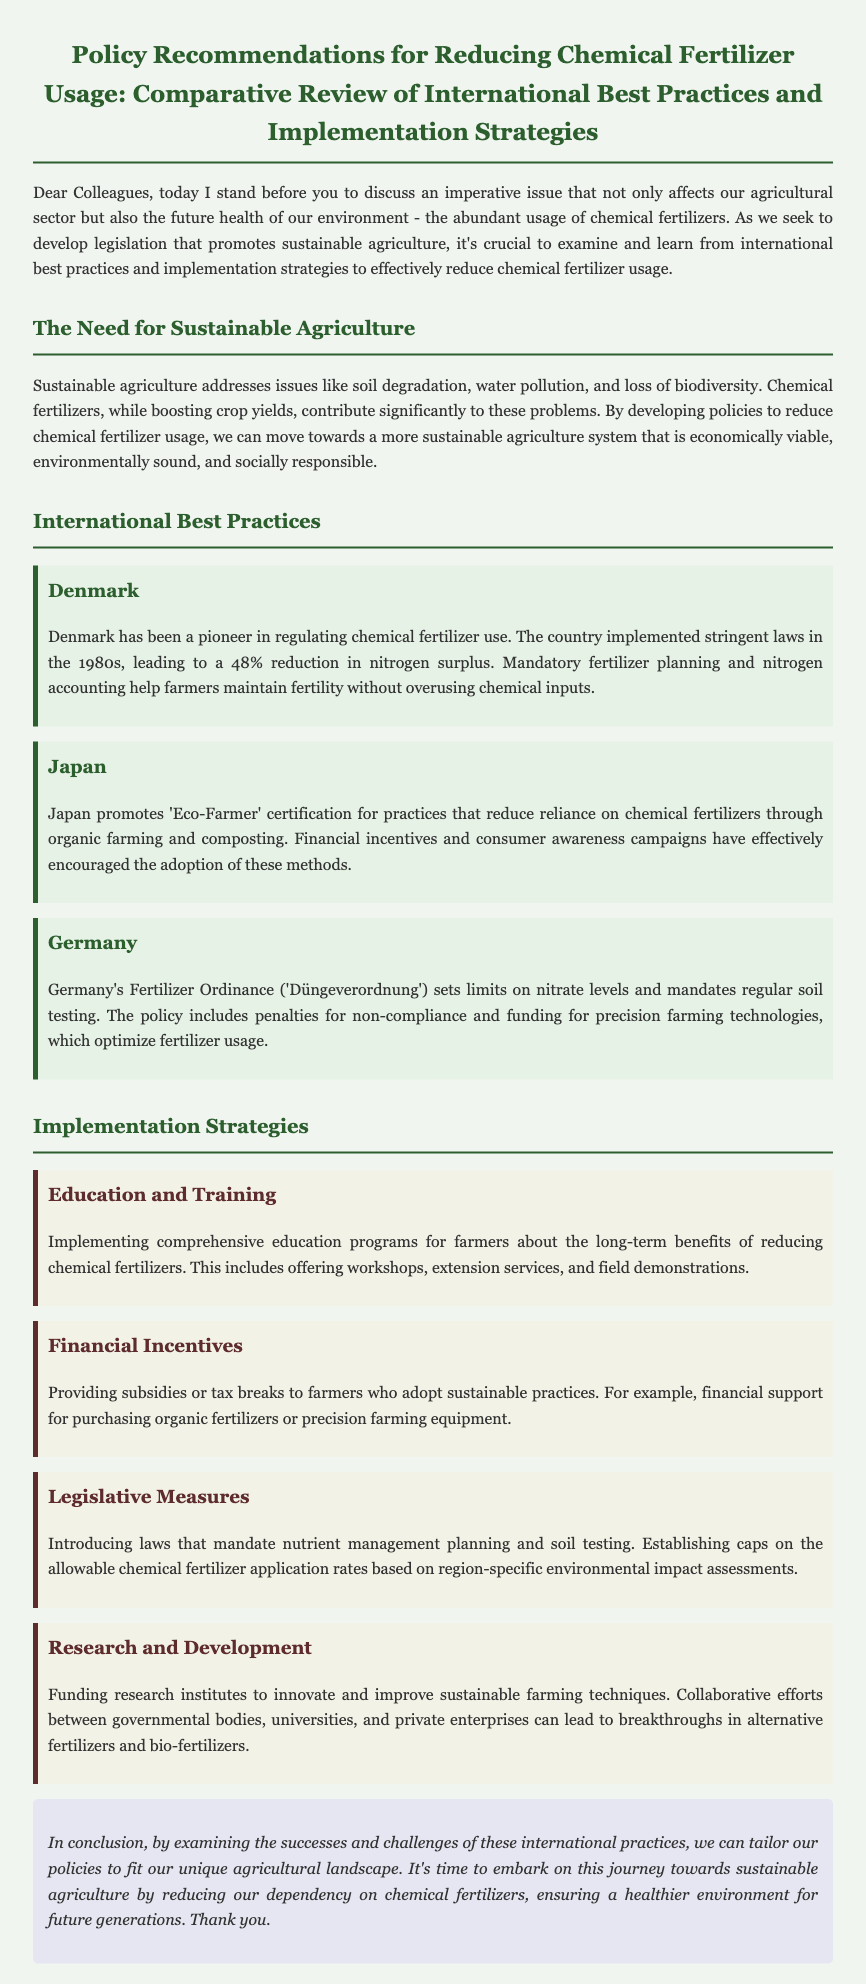What is the primary issue addressed in the document? The document emphasizes the imperative issue of abundant usage of chemical fertilizers affecting the agricultural sector and environmental health.
Answer: Chemical fertilizers Which country achieved a 48% reduction in nitrogen surplus? Denmark was noted for its successful regulation leading to a significant cut in nitrogen surplus since the 1980s.
Answer: Denmark What certification does Japan promote to reduce chemical fertilizer reliance? The document mentions 'Eco-Farmer' certification aimed at encouraging organic farming practices.
Answer: Eco-Farmer What legislative measure is introduced for nutrient management? The document states the introduction of laws that mandate nutrient management planning as part of the strategies discussed.
Answer: Nutrient management planning What percentage reduction of nitrogen surplus did Denmark achieve? The document highlights a specific percentage decrease in nitrogen surplus due to regulatory measures in Denmark.
Answer: 48% Which implementation strategy includes offers like workshops for farmers? The document describes an education and training strategy aimed at informing farmers about sustainable practices.
Answer: Education and Training What is suggested as a financial incentive for sustainable practices? Providing subsidies or tax breaks to farmers who adopt sustainable practices is recommended in the document.
Answer: Subsidies or tax breaks What role do research institutes play in the proposed implementation strategies? The document states that funding research institutes is a strategy aimed at innovating sustainable farming techniques.
Answer: Innovate sustainable farming techniques 